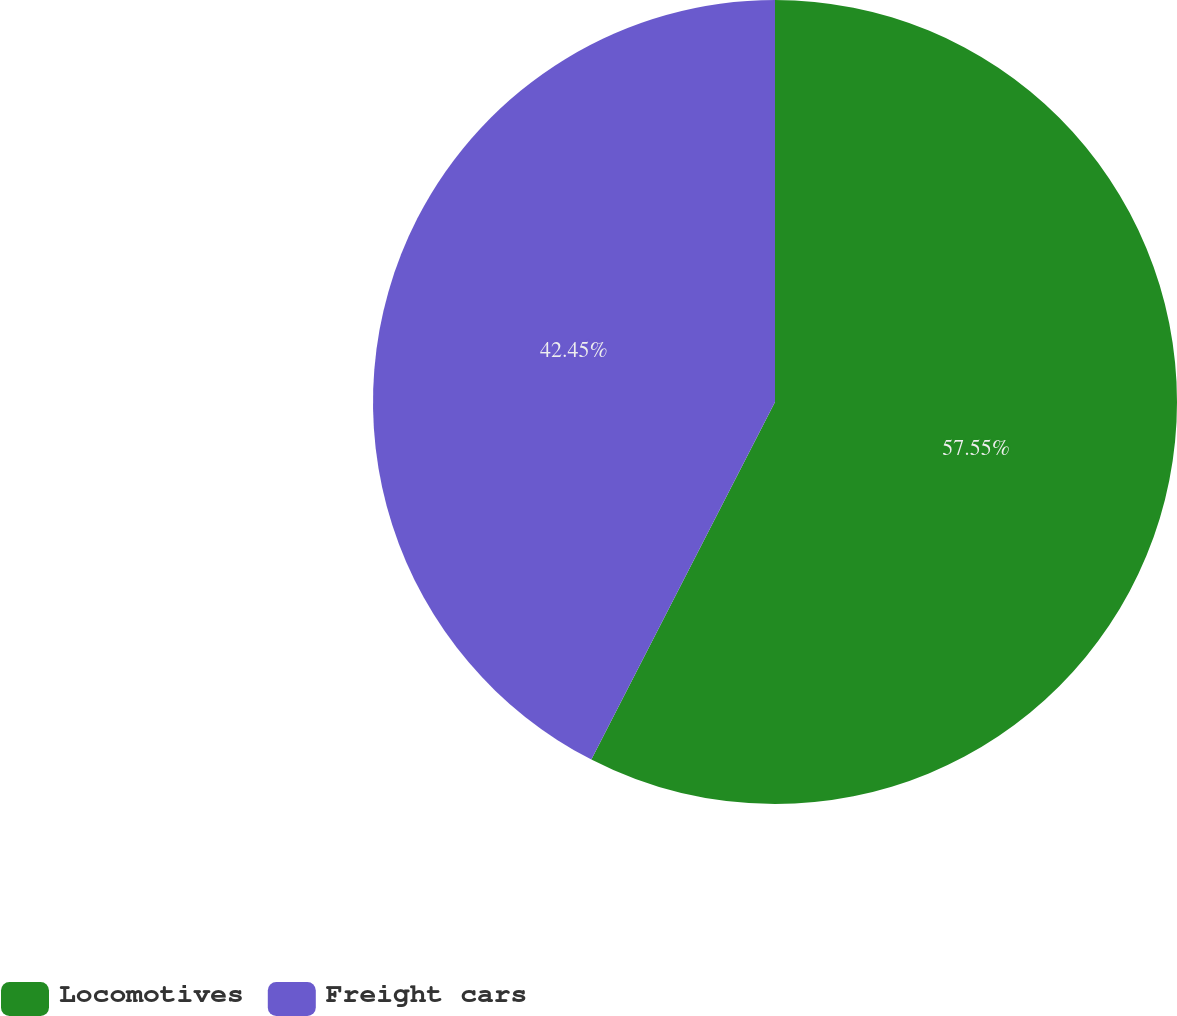Convert chart. <chart><loc_0><loc_0><loc_500><loc_500><pie_chart><fcel>Locomotives<fcel>Freight cars<nl><fcel>57.55%<fcel>42.45%<nl></chart> 